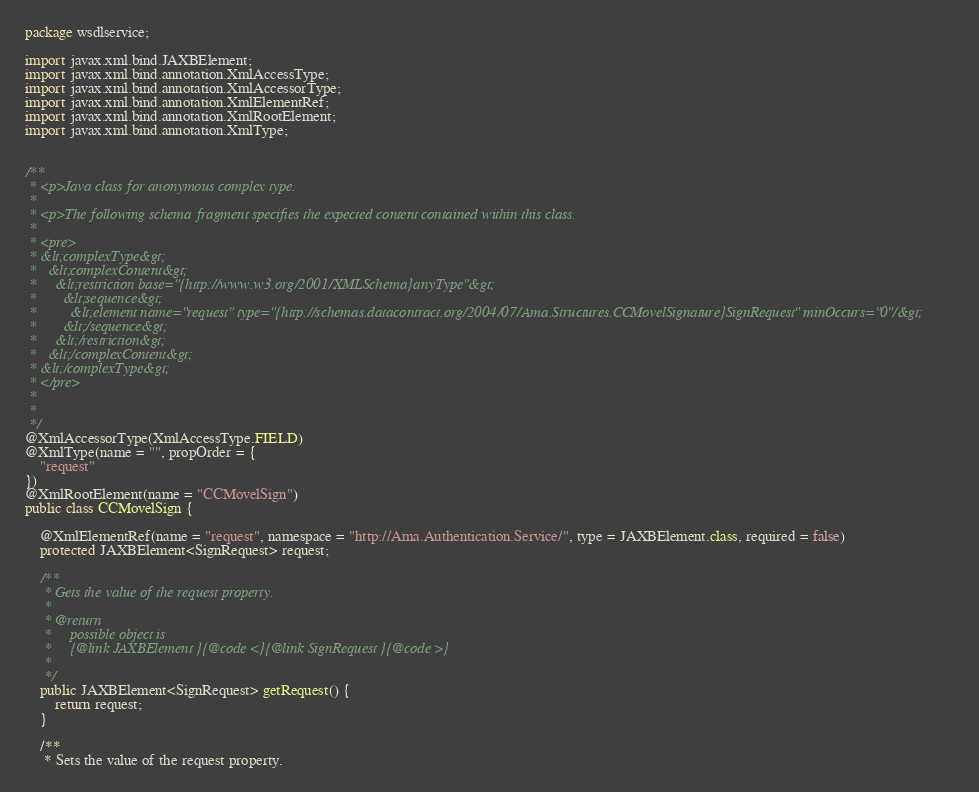<code> <loc_0><loc_0><loc_500><loc_500><_Java_>
package wsdlservice;

import javax.xml.bind.JAXBElement;
import javax.xml.bind.annotation.XmlAccessType;
import javax.xml.bind.annotation.XmlAccessorType;
import javax.xml.bind.annotation.XmlElementRef;
import javax.xml.bind.annotation.XmlRootElement;
import javax.xml.bind.annotation.XmlType;


/**
 * <p>Java class for anonymous complex type.
 * 
 * <p>The following schema fragment specifies the expected content contained within this class.
 * 
 * <pre>
 * &lt;complexType&gt;
 *   &lt;complexContent&gt;
 *     &lt;restriction base="{http://www.w3.org/2001/XMLSchema}anyType"&gt;
 *       &lt;sequence&gt;
 *         &lt;element name="request" type="{http://schemas.datacontract.org/2004/07/Ama.Structures.CCMovelSignature}SignRequest" minOccurs="0"/&gt;
 *       &lt;/sequence&gt;
 *     &lt;/restriction&gt;
 *   &lt;/complexContent&gt;
 * &lt;/complexType&gt;
 * </pre>
 * 
 * 
 */
@XmlAccessorType(XmlAccessType.FIELD)
@XmlType(name = "", propOrder = {
    "request"
})
@XmlRootElement(name = "CCMovelSign")
public class CCMovelSign {

    @XmlElementRef(name = "request", namespace = "http://Ama.Authentication.Service/", type = JAXBElement.class, required = false)
    protected JAXBElement<SignRequest> request;

    /**
     * Gets the value of the request property.
     * 
     * @return
     *     possible object is
     *     {@link JAXBElement }{@code <}{@link SignRequest }{@code >}
     *     
     */
    public JAXBElement<SignRequest> getRequest() {
        return request;
    }

    /**
     * Sets the value of the request property.</code> 